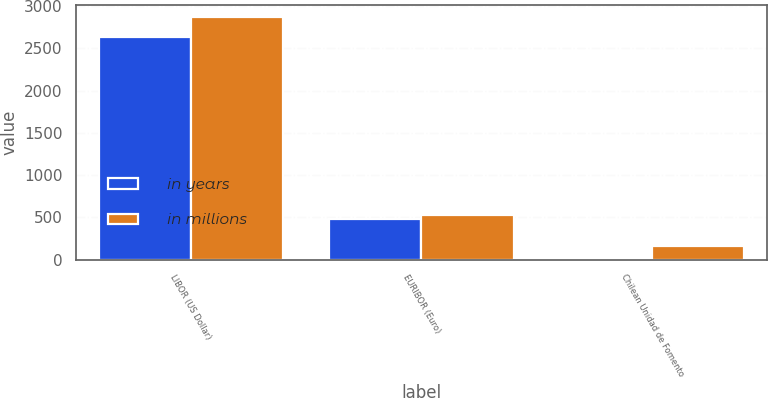Convert chart. <chart><loc_0><loc_0><loc_500><loc_500><stacked_bar_chart><ecel><fcel>LIBOR (US Dollar)<fcel>EURIBOR (Euro)<fcel>Chilean Unidad de Fomento<nl><fcel>in years<fcel>2639<fcel>482<fcel>4<nl><fcel>in millions<fcel>2872<fcel>524<fcel>159<nl></chart> 